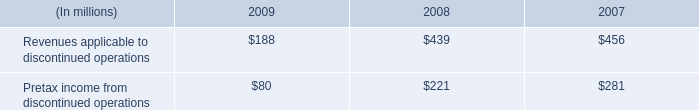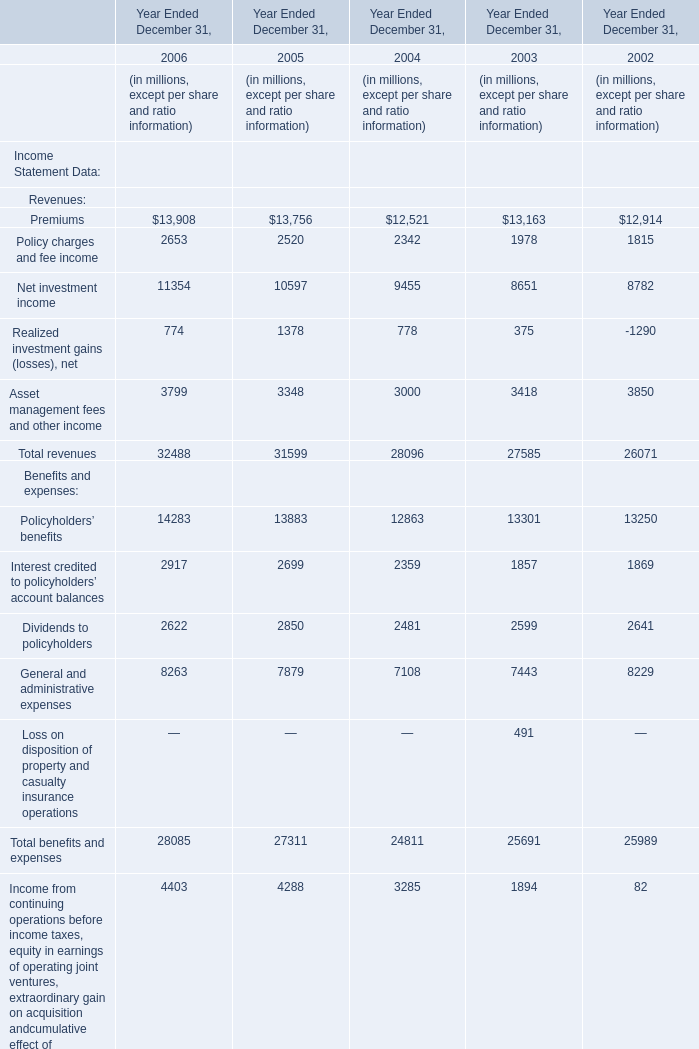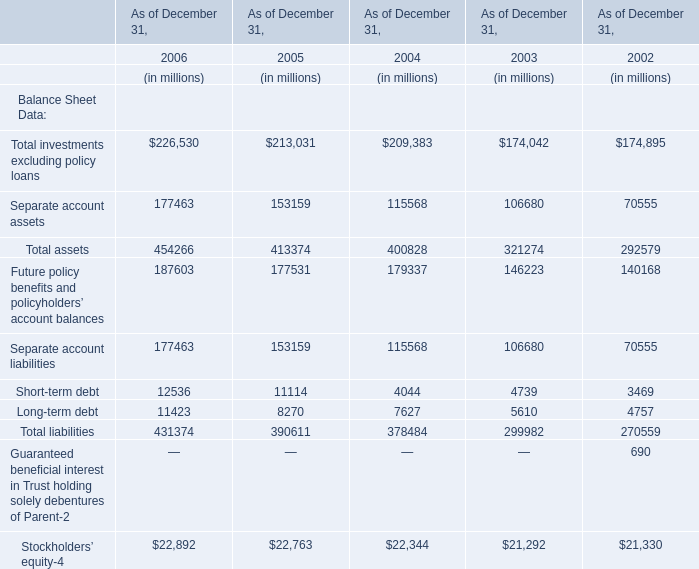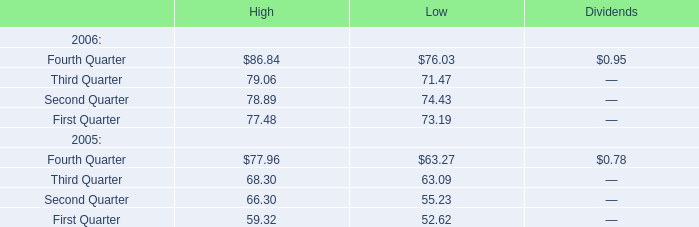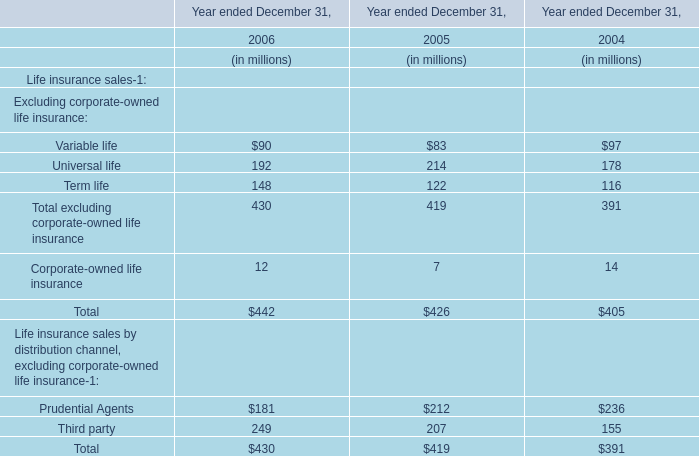In which year is Total investments excluding policy loans greater than 200000? 
Answer: 2006 2005 2004. 